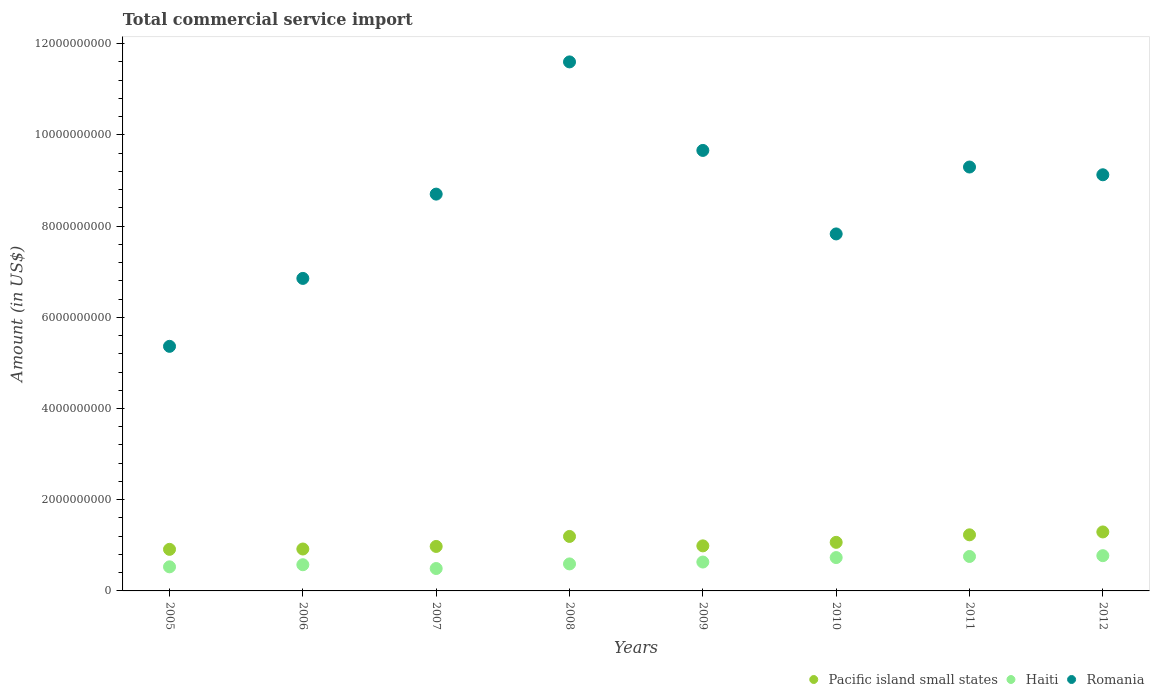Is the number of dotlines equal to the number of legend labels?
Provide a succinct answer. Yes. What is the total commercial service import in Haiti in 2008?
Ensure brevity in your answer.  5.92e+08. Across all years, what is the maximum total commercial service import in Pacific island small states?
Provide a succinct answer. 1.29e+09. Across all years, what is the minimum total commercial service import in Pacific island small states?
Make the answer very short. 9.12e+08. In which year was the total commercial service import in Romania maximum?
Provide a succinct answer. 2008. In which year was the total commercial service import in Haiti minimum?
Provide a succinct answer. 2007. What is the total total commercial service import in Pacific island small states in the graph?
Make the answer very short. 8.58e+09. What is the difference between the total commercial service import in Romania in 2008 and that in 2012?
Your response must be concise. 2.48e+09. What is the difference between the total commercial service import in Romania in 2007 and the total commercial service import in Haiti in 2008?
Provide a short and direct response. 8.11e+09. What is the average total commercial service import in Romania per year?
Your response must be concise. 8.55e+09. In the year 2012, what is the difference between the total commercial service import in Haiti and total commercial service import in Pacific island small states?
Offer a terse response. -5.20e+08. What is the ratio of the total commercial service import in Haiti in 2008 to that in 2011?
Offer a very short reply. 0.78. What is the difference between the highest and the second highest total commercial service import in Romania?
Give a very brief answer. 1.94e+09. What is the difference between the highest and the lowest total commercial service import in Pacific island small states?
Your answer should be compact. 3.82e+08. In how many years, is the total commercial service import in Haiti greater than the average total commercial service import in Haiti taken over all years?
Provide a short and direct response. 3. Is the sum of the total commercial service import in Pacific island small states in 2010 and 2011 greater than the maximum total commercial service import in Romania across all years?
Provide a short and direct response. No. Is it the case that in every year, the sum of the total commercial service import in Haiti and total commercial service import in Romania  is greater than the total commercial service import in Pacific island small states?
Your answer should be very brief. Yes. Does the total commercial service import in Pacific island small states monotonically increase over the years?
Ensure brevity in your answer.  No. Is the total commercial service import in Haiti strictly less than the total commercial service import in Pacific island small states over the years?
Provide a short and direct response. Yes. How many years are there in the graph?
Make the answer very short. 8. What is the difference between two consecutive major ticks on the Y-axis?
Make the answer very short. 2.00e+09. Are the values on the major ticks of Y-axis written in scientific E-notation?
Give a very brief answer. No. How many legend labels are there?
Provide a short and direct response. 3. How are the legend labels stacked?
Provide a short and direct response. Horizontal. What is the title of the graph?
Your answer should be very brief. Total commercial service import. What is the Amount (in US$) in Pacific island small states in 2005?
Provide a succinct answer. 9.12e+08. What is the Amount (in US$) of Haiti in 2005?
Keep it short and to the point. 5.28e+08. What is the Amount (in US$) in Romania in 2005?
Your response must be concise. 5.36e+09. What is the Amount (in US$) in Pacific island small states in 2006?
Provide a succinct answer. 9.19e+08. What is the Amount (in US$) in Haiti in 2006?
Your answer should be very brief. 5.74e+08. What is the Amount (in US$) in Romania in 2006?
Your answer should be compact. 6.85e+09. What is the Amount (in US$) in Pacific island small states in 2007?
Provide a succinct answer. 9.75e+08. What is the Amount (in US$) of Haiti in 2007?
Provide a short and direct response. 4.91e+08. What is the Amount (in US$) in Romania in 2007?
Your answer should be very brief. 8.70e+09. What is the Amount (in US$) in Pacific island small states in 2008?
Offer a very short reply. 1.19e+09. What is the Amount (in US$) of Haiti in 2008?
Make the answer very short. 5.92e+08. What is the Amount (in US$) of Romania in 2008?
Provide a succinct answer. 1.16e+1. What is the Amount (in US$) in Pacific island small states in 2009?
Offer a very short reply. 9.88e+08. What is the Amount (in US$) of Haiti in 2009?
Make the answer very short. 6.33e+08. What is the Amount (in US$) in Romania in 2009?
Offer a terse response. 9.66e+09. What is the Amount (in US$) of Pacific island small states in 2010?
Provide a short and direct response. 1.07e+09. What is the Amount (in US$) in Haiti in 2010?
Your answer should be very brief. 7.31e+08. What is the Amount (in US$) in Romania in 2010?
Your answer should be compact. 7.83e+09. What is the Amount (in US$) of Pacific island small states in 2011?
Make the answer very short. 1.23e+09. What is the Amount (in US$) in Haiti in 2011?
Ensure brevity in your answer.  7.55e+08. What is the Amount (in US$) in Romania in 2011?
Offer a terse response. 9.30e+09. What is the Amount (in US$) in Pacific island small states in 2012?
Your answer should be very brief. 1.29e+09. What is the Amount (in US$) of Haiti in 2012?
Your response must be concise. 7.73e+08. What is the Amount (in US$) in Romania in 2012?
Offer a very short reply. 9.12e+09. Across all years, what is the maximum Amount (in US$) in Pacific island small states?
Offer a very short reply. 1.29e+09. Across all years, what is the maximum Amount (in US$) in Haiti?
Offer a terse response. 7.73e+08. Across all years, what is the maximum Amount (in US$) in Romania?
Provide a short and direct response. 1.16e+1. Across all years, what is the minimum Amount (in US$) in Pacific island small states?
Ensure brevity in your answer.  9.12e+08. Across all years, what is the minimum Amount (in US$) of Haiti?
Give a very brief answer. 4.91e+08. Across all years, what is the minimum Amount (in US$) of Romania?
Make the answer very short. 5.36e+09. What is the total Amount (in US$) of Pacific island small states in the graph?
Offer a very short reply. 8.58e+09. What is the total Amount (in US$) of Haiti in the graph?
Give a very brief answer. 5.08e+09. What is the total Amount (in US$) in Romania in the graph?
Offer a terse response. 6.84e+1. What is the difference between the Amount (in US$) of Pacific island small states in 2005 and that in 2006?
Ensure brevity in your answer.  -7.53e+06. What is the difference between the Amount (in US$) in Haiti in 2005 and that in 2006?
Offer a very short reply. -4.62e+07. What is the difference between the Amount (in US$) in Romania in 2005 and that in 2006?
Provide a short and direct response. -1.49e+09. What is the difference between the Amount (in US$) of Pacific island small states in 2005 and that in 2007?
Your answer should be very brief. -6.38e+07. What is the difference between the Amount (in US$) of Haiti in 2005 and that in 2007?
Your answer should be very brief. 3.68e+07. What is the difference between the Amount (in US$) of Romania in 2005 and that in 2007?
Offer a terse response. -3.34e+09. What is the difference between the Amount (in US$) in Pacific island small states in 2005 and that in 2008?
Your response must be concise. -2.83e+08. What is the difference between the Amount (in US$) in Haiti in 2005 and that in 2008?
Your answer should be very brief. -6.41e+07. What is the difference between the Amount (in US$) in Romania in 2005 and that in 2008?
Your answer should be very brief. -6.24e+09. What is the difference between the Amount (in US$) of Pacific island small states in 2005 and that in 2009?
Ensure brevity in your answer.  -7.65e+07. What is the difference between the Amount (in US$) of Haiti in 2005 and that in 2009?
Keep it short and to the point. -1.05e+08. What is the difference between the Amount (in US$) of Romania in 2005 and that in 2009?
Make the answer very short. -4.30e+09. What is the difference between the Amount (in US$) in Pacific island small states in 2005 and that in 2010?
Your answer should be very brief. -1.53e+08. What is the difference between the Amount (in US$) in Haiti in 2005 and that in 2010?
Make the answer very short. -2.03e+08. What is the difference between the Amount (in US$) in Romania in 2005 and that in 2010?
Offer a very short reply. -2.46e+09. What is the difference between the Amount (in US$) in Pacific island small states in 2005 and that in 2011?
Your answer should be very brief. -3.19e+08. What is the difference between the Amount (in US$) of Haiti in 2005 and that in 2011?
Make the answer very short. -2.27e+08. What is the difference between the Amount (in US$) in Romania in 2005 and that in 2011?
Your answer should be compact. -3.93e+09. What is the difference between the Amount (in US$) of Pacific island small states in 2005 and that in 2012?
Your answer should be compact. -3.82e+08. What is the difference between the Amount (in US$) in Haiti in 2005 and that in 2012?
Keep it short and to the point. -2.45e+08. What is the difference between the Amount (in US$) of Romania in 2005 and that in 2012?
Provide a short and direct response. -3.76e+09. What is the difference between the Amount (in US$) of Pacific island small states in 2006 and that in 2007?
Ensure brevity in your answer.  -5.63e+07. What is the difference between the Amount (in US$) in Haiti in 2006 and that in 2007?
Make the answer very short. 8.30e+07. What is the difference between the Amount (in US$) in Romania in 2006 and that in 2007?
Offer a terse response. -1.85e+09. What is the difference between the Amount (in US$) in Pacific island small states in 2006 and that in 2008?
Your answer should be compact. -2.76e+08. What is the difference between the Amount (in US$) of Haiti in 2006 and that in 2008?
Give a very brief answer. -1.79e+07. What is the difference between the Amount (in US$) of Romania in 2006 and that in 2008?
Give a very brief answer. -4.75e+09. What is the difference between the Amount (in US$) in Pacific island small states in 2006 and that in 2009?
Your answer should be very brief. -6.89e+07. What is the difference between the Amount (in US$) in Haiti in 2006 and that in 2009?
Keep it short and to the point. -5.90e+07. What is the difference between the Amount (in US$) of Romania in 2006 and that in 2009?
Give a very brief answer. -2.81e+09. What is the difference between the Amount (in US$) of Pacific island small states in 2006 and that in 2010?
Keep it short and to the point. -1.46e+08. What is the difference between the Amount (in US$) in Haiti in 2006 and that in 2010?
Your answer should be very brief. -1.57e+08. What is the difference between the Amount (in US$) of Romania in 2006 and that in 2010?
Offer a terse response. -9.75e+08. What is the difference between the Amount (in US$) of Pacific island small states in 2006 and that in 2011?
Your response must be concise. -3.11e+08. What is the difference between the Amount (in US$) in Haiti in 2006 and that in 2011?
Make the answer very short. -1.81e+08. What is the difference between the Amount (in US$) of Romania in 2006 and that in 2011?
Offer a terse response. -2.44e+09. What is the difference between the Amount (in US$) of Pacific island small states in 2006 and that in 2012?
Give a very brief answer. -3.74e+08. What is the difference between the Amount (in US$) of Haiti in 2006 and that in 2012?
Your answer should be compact. -1.99e+08. What is the difference between the Amount (in US$) in Romania in 2006 and that in 2012?
Keep it short and to the point. -2.27e+09. What is the difference between the Amount (in US$) in Pacific island small states in 2007 and that in 2008?
Your answer should be very brief. -2.19e+08. What is the difference between the Amount (in US$) of Haiti in 2007 and that in 2008?
Make the answer very short. -1.01e+08. What is the difference between the Amount (in US$) of Romania in 2007 and that in 2008?
Ensure brevity in your answer.  -2.90e+09. What is the difference between the Amount (in US$) of Pacific island small states in 2007 and that in 2009?
Offer a very short reply. -1.26e+07. What is the difference between the Amount (in US$) in Haiti in 2007 and that in 2009?
Your answer should be compact. -1.42e+08. What is the difference between the Amount (in US$) in Romania in 2007 and that in 2009?
Your response must be concise. -9.58e+08. What is the difference between the Amount (in US$) of Pacific island small states in 2007 and that in 2010?
Give a very brief answer. -8.96e+07. What is the difference between the Amount (in US$) of Haiti in 2007 and that in 2010?
Offer a terse response. -2.40e+08. What is the difference between the Amount (in US$) of Romania in 2007 and that in 2010?
Keep it short and to the point. 8.73e+08. What is the difference between the Amount (in US$) in Pacific island small states in 2007 and that in 2011?
Your response must be concise. -2.55e+08. What is the difference between the Amount (in US$) of Haiti in 2007 and that in 2011?
Your answer should be compact. -2.64e+08. What is the difference between the Amount (in US$) of Romania in 2007 and that in 2011?
Make the answer very short. -5.94e+08. What is the difference between the Amount (in US$) in Pacific island small states in 2007 and that in 2012?
Provide a short and direct response. -3.18e+08. What is the difference between the Amount (in US$) in Haiti in 2007 and that in 2012?
Give a very brief answer. -2.82e+08. What is the difference between the Amount (in US$) in Romania in 2007 and that in 2012?
Ensure brevity in your answer.  -4.24e+08. What is the difference between the Amount (in US$) of Pacific island small states in 2008 and that in 2009?
Your answer should be very brief. 2.07e+08. What is the difference between the Amount (in US$) in Haiti in 2008 and that in 2009?
Provide a short and direct response. -4.11e+07. What is the difference between the Amount (in US$) in Romania in 2008 and that in 2009?
Offer a very short reply. 1.94e+09. What is the difference between the Amount (in US$) in Pacific island small states in 2008 and that in 2010?
Give a very brief answer. 1.30e+08. What is the difference between the Amount (in US$) of Haiti in 2008 and that in 2010?
Your response must be concise. -1.39e+08. What is the difference between the Amount (in US$) in Romania in 2008 and that in 2010?
Ensure brevity in your answer.  3.77e+09. What is the difference between the Amount (in US$) in Pacific island small states in 2008 and that in 2011?
Make the answer very short. -3.54e+07. What is the difference between the Amount (in US$) in Haiti in 2008 and that in 2011?
Offer a very short reply. -1.63e+08. What is the difference between the Amount (in US$) of Romania in 2008 and that in 2011?
Your answer should be compact. 2.30e+09. What is the difference between the Amount (in US$) in Pacific island small states in 2008 and that in 2012?
Provide a short and direct response. -9.85e+07. What is the difference between the Amount (in US$) in Haiti in 2008 and that in 2012?
Offer a very short reply. -1.81e+08. What is the difference between the Amount (in US$) in Romania in 2008 and that in 2012?
Offer a terse response. 2.48e+09. What is the difference between the Amount (in US$) of Pacific island small states in 2009 and that in 2010?
Give a very brief answer. -7.70e+07. What is the difference between the Amount (in US$) in Haiti in 2009 and that in 2010?
Your answer should be compact. -9.79e+07. What is the difference between the Amount (in US$) of Romania in 2009 and that in 2010?
Offer a terse response. 1.83e+09. What is the difference between the Amount (in US$) of Pacific island small states in 2009 and that in 2011?
Provide a succinct answer. -2.42e+08. What is the difference between the Amount (in US$) of Haiti in 2009 and that in 2011?
Ensure brevity in your answer.  -1.22e+08. What is the difference between the Amount (in US$) of Romania in 2009 and that in 2011?
Make the answer very short. 3.64e+08. What is the difference between the Amount (in US$) of Pacific island small states in 2009 and that in 2012?
Your answer should be compact. -3.05e+08. What is the difference between the Amount (in US$) of Haiti in 2009 and that in 2012?
Ensure brevity in your answer.  -1.40e+08. What is the difference between the Amount (in US$) of Romania in 2009 and that in 2012?
Give a very brief answer. 5.34e+08. What is the difference between the Amount (in US$) in Pacific island small states in 2010 and that in 2011?
Give a very brief answer. -1.65e+08. What is the difference between the Amount (in US$) in Haiti in 2010 and that in 2011?
Offer a very short reply. -2.42e+07. What is the difference between the Amount (in US$) of Romania in 2010 and that in 2011?
Offer a very short reply. -1.47e+09. What is the difference between the Amount (in US$) of Pacific island small states in 2010 and that in 2012?
Offer a terse response. -2.28e+08. What is the difference between the Amount (in US$) of Haiti in 2010 and that in 2012?
Provide a succinct answer. -4.17e+07. What is the difference between the Amount (in US$) in Romania in 2010 and that in 2012?
Offer a very short reply. -1.30e+09. What is the difference between the Amount (in US$) in Pacific island small states in 2011 and that in 2012?
Provide a succinct answer. -6.30e+07. What is the difference between the Amount (in US$) in Haiti in 2011 and that in 2012?
Ensure brevity in your answer.  -1.75e+07. What is the difference between the Amount (in US$) in Romania in 2011 and that in 2012?
Keep it short and to the point. 1.70e+08. What is the difference between the Amount (in US$) of Pacific island small states in 2005 and the Amount (in US$) of Haiti in 2006?
Your answer should be compact. 3.37e+08. What is the difference between the Amount (in US$) of Pacific island small states in 2005 and the Amount (in US$) of Romania in 2006?
Give a very brief answer. -5.94e+09. What is the difference between the Amount (in US$) in Haiti in 2005 and the Amount (in US$) in Romania in 2006?
Your answer should be very brief. -6.32e+09. What is the difference between the Amount (in US$) of Pacific island small states in 2005 and the Amount (in US$) of Haiti in 2007?
Your response must be concise. 4.20e+08. What is the difference between the Amount (in US$) in Pacific island small states in 2005 and the Amount (in US$) in Romania in 2007?
Keep it short and to the point. -7.79e+09. What is the difference between the Amount (in US$) of Haiti in 2005 and the Amount (in US$) of Romania in 2007?
Your answer should be very brief. -8.17e+09. What is the difference between the Amount (in US$) in Pacific island small states in 2005 and the Amount (in US$) in Haiti in 2008?
Offer a terse response. 3.19e+08. What is the difference between the Amount (in US$) in Pacific island small states in 2005 and the Amount (in US$) in Romania in 2008?
Make the answer very short. -1.07e+1. What is the difference between the Amount (in US$) in Haiti in 2005 and the Amount (in US$) in Romania in 2008?
Keep it short and to the point. -1.11e+1. What is the difference between the Amount (in US$) in Pacific island small states in 2005 and the Amount (in US$) in Haiti in 2009?
Make the answer very short. 2.78e+08. What is the difference between the Amount (in US$) of Pacific island small states in 2005 and the Amount (in US$) of Romania in 2009?
Provide a short and direct response. -8.75e+09. What is the difference between the Amount (in US$) in Haiti in 2005 and the Amount (in US$) in Romania in 2009?
Your response must be concise. -9.13e+09. What is the difference between the Amount (in US$) of Pacific island small states in 2005 and the Amount (in US$) of Haiti in 2010?
Your response must be concise. 1.80e+08. What is the difference between the Amount (in US$) in Pacific island small states in 2005 and the Amount (in US$) in Romania in 2010?
Your answer should be very brief. -6.92e+09. What is the difference between the Amount (in US$) in Haiti in 2005 and the Amount (in US$) in Romania in 2010?
Give a very brief answer. -7.30e+09. What is the difference between the Amount (in US$) of Pacific island small states in 2005 and the Amount (in US$) of Haiti in 2011?
Your response must be concise. 1.56e+08. What is the difference between the Amount (in US$) of Pacific island small states in 2005 and the Amount (in US$) of Romania in 2011?
Your answer should be very brief. -8.38e+09. What is the difference between the Amount (in US$) of Haiti in 2005 and the Amount (in US$) of Romania in 2011?
Your answer should be very brief. -8.77e+09. What is the difference between the Amount (in US$) in Pacific island small states in 2005 and the Amount (in US$) in Haiti in 2012?
Your response must be concise. 1.39e+08. What is the difference between the Amount (in US$) of Pacific island small states in 2005 and the Amount (in US$) of Romania in 2012?
Give a very brief answer. -8.21e+09. What is the difference between the Amount (in US$) of Haiti in 2005 and the Amount (in US$) of Romania in 2012?
Offer a very short reply. -8.60e+09. What is the difference between the Amount (in US$) of Pacific island small states in 2006 and the Amount (in US$) of Haiti in 2007?
Offer a terse response. 4.28e+08. What is the difference between the Amount (in US$) of Pacific island small states in 2006 and the Amount (in US$) of Romania in 2007?
Provide a succinct answer. -7.78e+09. What is the difference between the Amount (in US$) in Haiti in 2006 and the Amount (in US$) in Romania in 2007?
Ensure brevity in your answer.  -8.13e+09. What is the difference between the Amount (in US$) of Pacific island small states in 2006 and the Amount (in US$) of Haiti in 2008?
Provide a short and direct response. 3.27e+08. What is the difference between the Amount (in US$) of Pacific island small states in 2006 and the Amount (in US$) of Romania in 2008?
Ensure brevity in your answer.  -1.07e+1. What is the difference between the Amount (in US$) of Haiti in 2006 and the Amount (in US$) of Romania in 2008?
Ensure brevity in your answer.  -1.10e+1. What is the difference between the Amount (in US$) of Pacific island small states in 2006 and the Amount (in US$) of Haiti in 2009?
Your answer should be compact. 2.86e+08. What is the difference between the Amount (in US$) in Pacific island small states in 2006 and the Amount (in US$) in Romania in 2009?
Provide a succinct answer. -8.74e+09. What is the difference between the Amount (in US$) of Haiti in 2006 and the Amount (in US$) of Romania in 2009?
Offer a terse response. -9.08e+09. What is the difference between the Amount (in US$) of Pacific island small states in 2006 and the Amount (in US$) of Haiti in 2010?
Offer a terse response. 1.88e+08. What is the difference between the Amount (in US$) of Pacific island small states in 2006 and the Amount (in US$) of Romania in 2010?
Keep it short and to the point. -6.91e+09. What is the difference between the Amount (in US$) in Haiti in 2006 and the Amount (in US$) in Romania in 2010?
Offer a terse response. -7.25e+09. What is the difference between the Amount (in US$) in Pacific island small states in 2006 and the Amount (in US$) in Haiti in 2011?
Provide a short and direct response. 1.64e+08. What is the difference between the Amount (in US$) of Pacific island small states in 2006 and the Amount (in US$) of Romania in 2011?
Provide a succinct answer. -8.38e+09. What is the difference between the Amount (in US$) of Haiti in 2006 and the Amount (in US$) of Romania in 2011?
Offer a terse response. -8.72e+09. What is the difference between the Amount (in US$) in Pacific island small states in 2006 and the Amount (in US$) in Haiti in 2012?
Give a very brief answer. 1.46e+08. What is the difference between the Amount (in US$) in Pacific island small states in 2006 and the Amount (in US$) in Romania in 2012?
Your answer should be very brief. -8.21e+09. What is the difference between the Amount (in US$) in Haiti in 2006 and the Amount (in US$) in Romania in 2012?
Provide a succinct answer. -8.55e+09. What is the difference between the Amount (in US$) in Pacific island small states in 2007 and the Amount (in US$) in Haiti in 2008?
Give a very brief answer. 3.83e+08. What is the difference between the Amount (in US$) of Pacific island small states in 2007 and the Amount (in US$) of Romania in 2008?
Ensure brevity in your answer.  -1.06e+1. What is the difference between the Amount (in US$) in Haiti in 2007 and the Amount (in US$) in Romania in 2008?
Give a very brief answer. -1.11e+1. What is the difference between the Amount (in US$) in Pacific island small states in 2007 and the Amount (in US$) in Haiti in 2009?
Your response must be concise. 3.42e+08. What is the difference between the Amount (in US$) in Pacific island small states in 2007 and the Amount (in US$) in Romania in 2009?
Provide a succinct answer. -8.68e+09. What is the difference between the Amount (in US$) of Haiti in 2007 and the Amount (in US$) of Romania in 2009?
Ensure brevity in your answer.  -9.17e+09. What is the difference between the Amount (in US$) of Pacific island small states in 2007 and the Amount (in US$) of Haiti in 2010?
Give a very brief answer. 2.44e+08. What is the difference between the Amount (in US$) in Pacific island small states in 2007 and the Amount (in US$) in Romania in 2010?
Make the answer very short. -6.85e+09. What is the difference between the Amount (in US$) of Haiti in 2007 and the Amount (in US$) of Romania in 2010?
Provide a succinct answer. -7.34e+09. What is the difference between the Amount (in US$) in Pacific island small states in 2007 and the Amount (in US$) in Haiti in 2011?
Provide a short and direct response. 2.20e+08. What is the difference between the Amount (in US$) in Pacific island small states in 2007 and the Amount (in US$) in Romania in 2011?
Make the answer very short. -8.32e+09. What is the difference between the Amount (in US$) in Haiti in 2007 and the Amount (in US$) in Romania in 2011?
Give a very brief answer. -8.80e+09. What is the difference between the Amount (in US$) of Pacific island small states in 2007 and the Amount (in US$) of Haiti in 2012?
Offer a very short reply. 2.02e+08. What is the difference between the Amount (in US$) in Pacific island small states in 2007 and the Amount (in US$) in Romania in 2012?
Your answer should be compact. -8.15e+09. What is the difference between the Amount (in US$) in Haiti in 2007 and the Amount (in US$) in Romania in 2012?
Provide a succinct answer. -8.63e+09. What is the difference between the Amount (in US$) in Pacific island small states in 2008 and the Amount (in US$) in Haiti in 2009?
Your answer should be very brief. 5.61e+08. What is the difference between the Amount (in US$) in Pacific island small states in 2008 and the Amount (in US$) in Romania in 2009?
Offer a terse response. -8.46e+09. What is the difference between the Amount (in US$) in Haiti in 2008 and the Amount (in US$) in Romania in 2009?
Offer a terse response. -9.07e+09. What is the difference between the Amount (in US$) in Pacific island small states in 2008 and the Amount (in US$) in Haiti in 2010?
Offer a very short reply. 4.63e+08. What is the difference between the Amount (in US$) of Pacific island small states in 2008 and the Amount (in US$) of Romania in 2010?
Provide a succinct answer. -6.63e+09. What is the difference between the Amount (in US$) of Haiti in 2008 and the Amount (in US$) of Romania in 2010?
Your answer should be compact. -7.24e+09. What is the difference between the Amount (in US$) in Pacific island small states in 2008 and the Amount (in US$) in Haiti in 2011?
Ensure brevity in your answer.  4.39e+08. What is the difference between the Amount (in US$) of Pacific island small states in 2008 and the Amount (in US$) of Romania in 2011?
Keep it short and to the point. -8.10e+09. What is the difference between the Amount (in US$) of Haiti in 2008 and the Amount (in US$) of Romania in 2011?
Your response must be concise. -8.70e+09. What is the difference between the Amount (in US$) in Pacific island small states in 2008 and the Amount (in US$) in Haiti in 2012?
Give a very brief answer. 4.22e+08. What is the difference between the Amount (in US$) of Pacific island small states in 2008 and the Amount (in US$) of Romania in 2012?
Give a very brief answer. -7.93e+09. What is the difference between the Amount (in US$) of Haiti in 2008 and the Amount (in US$) of Romania in 2012?
Your answer should be very brief. -8.53e+09. What is the difference between the Amount (in US$) of Pacific island small states in 2009 and the Amount (in US$) of Haiti in 2010?
Your response must be concise. 2.57e+08. What is the difference between the Amount (in US$) in Pacific island small states in 2009 and the Amount (in US$) in Romania in 2010?
Ensure brevity in your answer.  -6.84e+09. What is the difference between the Amount (in US$) of Haiti in 2009 and the Amount (in US$) of Romania in 2010?
Keep it short and to the point. -7.19e+09. What is the difference between the Amount (in US$) of Pacific island small states in 2009 and the Amount (in US$) of Haiti in 2011?
Offer a very short reply. 2.33e+08. What is the difference between the Amount (in US$) of Pacific island small states in 2009 and the Amount (in US$) of Romania in 2011?
Provide a short and direct response. -8.31e+09. What is the difference between the Amount (in US$) in Haiti in 2009 and the Amount (in US$) in Romania in 2011?
Offer a very short reply. -8.66e+09. What is the difference between the Amount (in US$) of Pacific island small states in 2009 and the Amount (in US$) of Haiti in 2012?
Give a very brief answer. 2.15e+08. What is the difference between the Amount (in US$) of Pacific island small states in 2009 and the Amount (in US$) of Romania in 2012?
Give a very brief answer. -8.14e+09. What is the difference between the Amount (in US$) of Haiti in 2009 and the Amount (in US$) of Romania in 2012?
Your answer should be very brief. -8.49e+09. What is the difference between the Amount (in US$) in Pacific island small states in 2010 and the Amount (in US$) in Haiti in 2011?
Keep it short and to the point. 3.10e+08. What is the difference between the Amount (in US$) of Pacific island small states in 2010 and the Amount (in US$) of Romania in 2011?
Provide a succinct answer. -8.23e+09. What is the difference between the Amount (in US$) in Haiti in 2010 and the Amount (in US$) in Romania in 2011?
Your response must be concise. -8.56e+09. What is the difference between the Amount (in US$) of Pacific island small states in 2010 and the Amount (in US$) of Haiti in 2012?
Your response must be concise. 2.92e+08. What is the difference between the Amount (in US$) in Pacific island small states in 2010 and the Amount (in US$) in Romania in 2012?
Give a very brief answer. -8.06e+09. What is the difference between the Amount (in US$) of Haiti in 2010 and the Amount (in US$) of Romania in 2012?
Your response must be concise. -8.39e+09. What is the difference between the Amount (in US$) of Pacific island small states in 2011 and the Amount (in US$) of Haiti in 2012?
Offer a very short reply. 4.57e+08. What is the difference between the Amount (in US$) of Pacific island small states in 2011 and the Amount (in US$) of Romania in 2012?
Offer a terse response. -7.89e+09. What is the difference between the Amount (in US$) in Haiti in 2011 and the Amount (in US$) in Romania in 2012?
Ensure brevity in your answer.  -8.37e+09. What is the average Amount (in US$) of Pacific island small states per year?
Offer a terse response. 1.07e+09. What is the average Amount (in US$) of Haiti per year?
Offer a very short reply. 6.35e+08. What is the average Amount (in US$) in Romania per year?
Offer a terse response. 8.55e+09. In the year 2005, what is the difference between the Amount (in US$) of Pacific island small states and Amount (in US$) of Haiti?
Provide a succinct answer. 3.83e+08. In the year 2005, what is the difference between the Amount (in US$) in Pacific island small states and Amount (in US$) in Romania?
Keep it short and to the point. -4.45e+09. In the year 2005, what is the difference between the Amount (in US$) of Haiti and Amount (in US$) of Romania?
Offer a terse response. -4.84e+09. In the year 2006, what is the difference between the Amount (in US$) of Pacific island small states and Amount (in US$) of Haiti?
Your response must be concise. 3.45e+08. In the year 2006, what is the difference between the Amount (in US$) in Pacific island small states and Amount (in US$) in Romania?
Your answer should be very brief. -5.93e+09. In the year 2006, what is the difference between the Amount (in US$) in Haiti and Amount (in US$) in Romania?
Make the answer very short. -6.28e+09. In the year 2007, what is the difference between the Amount (in US$) in Pacific island small states and Amount (in US$) in Haiti?
Your response must be concise. 4.84e+08. In the year 2007, what is the difference between the Amount (in US$) of Pacific island small states and Amount (in US$) of Romania?
Provide a short and direct response. -7.73e+09. In the year 2007, what is the difference between the Amount (in US$) in Haiti and Amount (in US$) in Romania?
Ensure brevity in your answer.  -8.21e+09. In the year 2008, what is the difference between the Amount (in US$) of Pacific island small states and Amount (in US$) of Haiti?
Offer a terse response. 6.02e+08. In the year 2008, what is the difference between the Amount (in US$) in Pacific island small states and Amount (in US$) in Romania?
Make the answer very short. -1.04e+1. In the year 2008, what is the difference between the Amount (in US$) of Haiti and Amount (in US$) of Romania?
Your response must be concise. -1.10e+1. In the year 2009, what is the difference between the Amount (in US$) of Pacific island small states and Amount (in US$) of Haiti?
Keep it short and to the point. 3.55e+08. In the year 2009, what is the difference between the Amount (in US$) in Pacific island small states and Amount (in US$) in Romania?
Give a very brief answer. -8.67e+09. In the year 2009, what is the difference between the Amount (in US$) of Haiti and Amount (in US$) of Romania?
Your answer should be compact. -9.03e+09. In the year 2010, what is the difference between the Amount (in US$) in Pacific island small states and Amount (in US$) in Haiti?
Your answer should be very brief. 3.34e+08. In the year 2010, what is the difference between the Amount (in US$) of Pacific island small states and Amount (in US$) of Romania?
Provide a short and direct response. -6.76e+09. In the year 2010, what is the difference between the Amount (in US$) in Haiti and Amount (in US$) in Romania?
Offer a very short reply. -7.10e+09. In the year 2011, what is the difference between the Amount (in US$) of Pacific island small states and Amount (in US$) of Haiti?
Give a very brief answer. 4.75e+08. In the year 2011, what is the difference between the Amount (in US$) in Pacific island small states and Amount (in US$) in Romania?
Keep it short and to the point. -8.06e+09. In the year 2011, what is the difference between the Amount (in US$) in Haiti and Amount (in US$) in Romania?
Provide a short and direct response. -8.54e+09. In the year 2012, what is the difference between the Amount (in US$) of Pacific island small states and Amount (in US$) of Haiti?
Your answer should be compact. 5.20e+08. In the year 2012, what is the difference between the Amount (in US$) in Pacific island small states and Amount (in US$) in Romania?
Provide a short and direct response. -7.83e+09. In the year 2012, what is the difference between the Amount (in US$) of Haiti and Amount (in US$) of Romania?
Make the answer very short. -8.35e+09. What is the ratio of the Amount (in US$) of Haiti in 2005 to that in 2006?
Ensure brevity in your answer.  0.92. What is the ratio of the Amount (in US$) of Romania in 2005 to that in 2006?
Ensure brevity in your answer.  0.78. What is the ratio of the Amount (in US$) in Pacific island small states in 2005 to that in 2007?
Give a very brief answer. 0.93. What is the ratio of the Amount (in US$) of Haiti in 2005 to that in 2007?
Keep it short and to the point. 1.07. What is the ratio of the Amount (in US$) of Romania in 2005 to that in 2007?
Offer a terse response. 0.62. What is the ratio of the Amount (in US$) of Pacific island small states in 2005 to that in 2008?
Offer a very short reply. 0.76. What is the ratio of the Amount (in US$) in Haiti in 2005 to that in 2008?
Ensure brevity in your answer.  0.89. What is the ratio of the Amount (in US$) of Romania in 2005 to that in 2008?
Offer a very short reply. 0.46. What is the ratio of the Amount (in US$) in Pacific island small states in 2005 to that in 2009?
Your answer should be very brief. 0.92. What is the ratio of the Amount (in US$) of Haiti in 2005 to that in 2009?
Provide a short and direct response. 0.83. What is the ratio of the Amount (in US$) in Romania in 2005 to that in 2009?
Your answer should be very brief. 0.56. What is the ratio of the Amount (in US$) in Pacific island small states in 2005 to that in 2010?
Offer a very short reply. 0.86. What is the ratio of the Amount (in US$) of Haiti in 2005 to that in 2010?
Your response must be concise. 0.72. What is the ratio of the Amount (in US$) in Romania in 2005 to that in 2010?
Your response must be concise. 0.69. What is the ratio of the Amount (in US$) of Pacific island small states in 2005 to that in 2011?
Offer a terse response. 0.74. What is the ratio of the Amount (in US$) of Haiti in 2005 to that in 2011?
Offer a terse response. 0.7. What is the ratio of the Amount (in US$) of Romania in 2005 to that in 2011?
Provide a succinct answer. 0.58. What is the ratio of the Amount (in US$) in Pacific island small states in 2005 to that in 2012?
Ensure brevity in your answer.  0.7. What is the ratio of the Amount (in US$) of Haiti in 2005 to that in 2012?
Keep it short and to the point. 0.68. What is the ratio of the Amount (in US$) of Romania in 2005 to that in 2012?
Give a very brief answer. 0.59. What is the ratio of the Amount (in US$) of Pacific island small states in 2006 to that in 2007?
Offer a very short reply. 0.94. What is the ratio of the Amount (in US$) of Haiti in 2006 to that in 2007?
Ensure brevity in your answer.  1.17. What is the ratio of the Amount (in US$) of Romania in 2006 to that in 2007?
Give a very brief answer. 0.79. What is the ratio of the Amount (in US$) in Pacific island small states in 2006 to that in 2008?
Offer a terse response. 0.77. What is the ratio of the Amount (in US$) of Haiti in 2006 to that in 2008?
Make the answer very short. 0.97. What is the ratio of the Amount (in US$) in Romania in 2006 to that in 2008?
Your answer should be compact. 0.59. What is the ratio of the Amount (in US$) in Pacific island small states in 2006 to that in 2009?
Keep it short and to the point. 0.93. What is the ratio of the Amount (in US$) in Haiti in 2006 to that in 2009?
Give a very brief answer. 0.91. What is the ratio of the Amount (in US$) in Romania in 2006 to that in 2009?
Your answer should be very brief. 0.71. What is the ratio of the Amount (in US$) in Pacific island small states in 2006 to that in 2010?
Offer a very short reply. 0.86. What is the ratio of the Amount (in US$) of Haiti in 2006 to that in 2010?
Make the answer very short. 0.79. What is the ratio of the Amount (in US$) of Romania in 2006 to that in 2010?
Keep it short and to the point. 0.88. What is the ratio of the Amount (in US$) of Pacific island small states in 2006 to that in 2011?
Ensure brevity in your answer.  0.75. What is the ratio of the Amount (in US$) of Haiti in 2006 to that in 2011?
Provide a short and direct response. 0.76. What is the ratio of the Amount (in US$) in Romania in 2006 to that in 2011?
Your answer should be very brief. 0.74. What is the ratio of the Amount (in US$) in Pacific island small states in 2006 to that in 2012?
Your response must be concise. 0.71. What is the ratio of the Amount (in US$) in Haiti in 2006 to that in 2012?
Your answer should be compact. 0.74. What is the ratio of the Amount (in US$) of Romania in 2006 to that in 2012?
Your response must be concise. 0.75. What is the ratio of the Amount (in US$) in Pacific island small states in 2007 to that in 2008?
Give a very brief answer. 0.82. What is the ratio of the Amount (in US$) of Haiti in 2007 to that in 2008?
Give a very brief answer. 0.83. What is the ratio of the Amount (in US$) of Romania in 2007 to that in 2008?
Your answer should be compact. 0.75. What is the ratio of the Amount (in US$) of Pacific island small states in 2007 to that in 2009?
Offer a very short reply. 0.99. What is the ratio of the Amount (in US$) of Haiti in 2007 to that in 2009?
Provide a short and direct response. 0.78. What is the ratio of the Amount (in US$) in Romania in 2007 to that in 2009?
Ensure brevity in your answer.  0.9. What is the ratio of the Amount (in US$) of Pacific island small states in 2007 to that in 2010?
Keep it short and to the point. 0.92. What is the ratio of the Amount (in US$) in Haiti in 2007 to that in 2010?
Give a very brief answer. 0.67. What is the ratio of the Amount (in US$) in Romania in 2007 to that in 2010?
Provide a succinct answer. 1.11. What is the ratio of the Amount (in US$) of Pacific island small states in 2007 to that in 2011?
Your answer should be very brief. 0.79. What is the ratio of the Amount (in US$) of Haiti in 2007 to that in 2011?
Offer a very short reply. 0.65. What is the ratio of the Amount (in US$) in Romania in 2007 to that in 2011?
Your answer should be very brief. 0.94. What is the ratio of the Amount (in US$) of Pacific island small states in 2007 to that in 2012?
Keep it short and to the point. 0.75. What is the ratio of the Amount (in US$) in Haiti in 2007 to that in 2012?
Your response must be concise. 0.64. What is the ratio of the Amount (in US$) in Romania in 2007 to that in 2012?
Provide a succinct answer. 0.95. What is the ratio of the Amount (in US$) of Pacific island small states in 2008 to that in 2009?
Make the answer very short. 1.21. What is the ratio of the Amount (in US$) of Haiti in 2008 to that in 2009?
Provide a succinct answer. 0.94. What is the ratio of the Amount (in US$) of Romania in 2008 to that in 2009?
Offer a very short reply. 1.2. What is the ratio of the Amount (in US$) in Pacific island small states in 2008 to that in 2010?
Your answer should be very brief. 1.12. What is the ratio of the Amount (in US$) in Haiti in 2008 to that in 2010?
Provide a succinct answer. 0.81. What is the ratio of the Amount (in US$) in Romania in 2008 to that in 2010?
Your response must be concise. 1.48. What is the ratio of the Amount (in US$) in Pacific island small states in 2008 to that in 2011?
Offer a very short reply. 0.97. What is the ratio of the Amount (in US$) in Haiti in 2008 to that in 2011?
Give a very brief answer. 0.78. What is the ratio of the Amount (in US$) of Romania in 2008 to that in 2011?
Give a very brief answer. 1.25. What is the ratio of the Amount (in US$) of Pacific island small states in 2008 to that in 2012?
Your answer should be compact. 0.92. What is the ratio of the Amount (in US$) of Haiti in 2008 to that in 2012?
Offer a terse response. 0.77. What is the ratio of the Amount (in US$) in Romania in 2008 to that in 2012?
Your answer should be very brief. 1.27. What is the ratio of the Amount (in US$) in Pacific island small states in 2009 to that in 2010?
Your response must be concise. 0.93. What is the ratio of the Amount (in US$) of Haiti in 2009 to that in 2010?
Give a very brief answer. 0.87. What is the ratio of the Amount (in US$) of Romania in 2009 to that in 2010?
Your answer should be compact. 1.23. What is the ratio of the Amount (in US$) of Pacific island small states in 2009 to that in 2011?
Provide a short and direct response. 0.8. What is the ratio of the Amount (in US$) of Haiti in 2009 to that in 2011?
Provide a succinct answer. 0.84. What is the ratio of the Amount (in US$) in Romania in 2009 to that in 2011?
Make the answer very short. 1.04. What is the ratio of the Amount (in US$) in Pacific island small states in 2009 to that in 2012?
Offer a terse response. 0.76. What is the ratio of the Amount (in US$) in Haiti in 2009 to that in 2012?
Offer a very short reply. 0.82. What is the ratio of the Amount (in US$) of Romania in 2009 to that in 2012?
Ensure brevity in your answer.  1.06. What is the ratio of the Amount (in US$) in Pacific island small states in 2010 to that in 2011?
Make the answer very short. 0.87. What is the ratio of the Amount (in US$) of Haiti in 2010 to that in 2011?
Keep it short and to the point. 0.97. What is the ratio of the Amount (in US$) of Romania in 2010 to that in 2011?
Provide a succinct answer. 0.84. What is the ratio of the Amount (in US$) in Pacific island small states in 2010 to that in 2012?
Offer a very short reply. 0.82. What is the ratio of the Amount (in US$) in Haiti in 2010 to that in 2012?
Offer a very short reply. 0.95. What is the ratio of the Amount (in US$) of Romania in 2010 to that in 2012?
Ensure brevity in your answer.  0.86. What is the ratio of the Amount (in US$) of Pacific island small states in 2011 to that in 2012?
Offer a very short reply. 0.95. What is the ratio of the Amount (in US$) of Haiti in 2011 to that in 2012?
Make the answer very short. 0.98. What is the ratio of the Amount (in US$) in Romania in 2011 to that in 2012?
Provide a succinct answer. 1.02. What is the difference between the highest and the second highest Amount (in US$) in Pacific island small states?
Ensure brevity in your answer.  6.30e+07. What is the difference between the highest and the second highest Amount (in US$) in Haiti?
Make the answer very short. 1.75e+07. What is the difference between the highest and the second highest Amount (in US$) of Romania?
Offer a very short reply. 1.94e+09. What is the difference between the highest and the lowest Amount (in US$) in Pacific island small states?
Your answer should be compact. 3.82e+08. What is the difference between the highest and the lowest Amount (in US$) of Haiti?
Make the answer very short. 2.82e+08. What is the difference between the highest and the lowest Amount (in US$) in Romania?
Provide a succinct answer. 6.24e+09. 